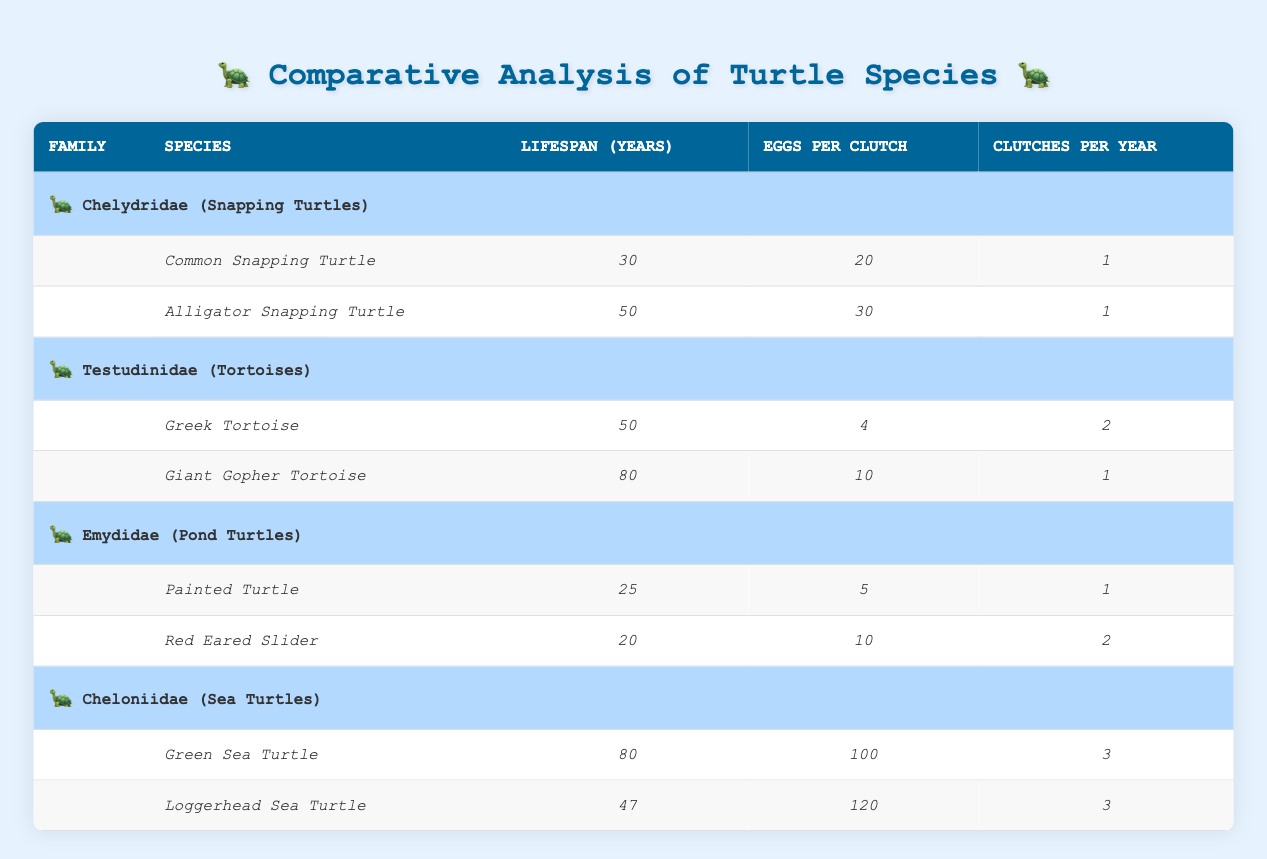What is the lifespan of the Common Snapping Turtle? The table lists the lifespan of the Common Snapping Turtle under the Chelydridae family, noting it is 30 years.
Answer: 30 years How many eggs does the Loggerhead Sea Turtle lay per clutch? The table specifies that the Loggerhead Sea Turtle lays 120 eggs per clutch, as shown in its reproductive rate under the Cheloniidae family.
Answer: 120 eggs Which family has the longest-lived species on average? The longest lifespan in the table is associated with the Giant Gopher Tortoise and the Green Sea Turtle, both having a lifespan of 80 years. Calculating the average of the longest lifespans from families: (80 + 80 + 50 + 50 + 47 + 30 + 25 + 20) / 8 = 50.625, showing that both families have species that significantly contribute to this average.
Answer: Testudinidae and Cheloniidae Is the Reproductive Rate of the Giant Gopher Tortoise higher than that of the Greek Tortoise? The Giant Gopher Tortoise has a reproductive rate of 10 eggs per clutch with 1 clutch per year, leading to a total of 10 eggs per year. In comparison, the Greek Tortoise has 4 eggs per clutch and 2 clutches per year, resulting in a total of 8 eggs per year. Therefore, the Giant Gopher Tortoise has a higher reproductive rate.
Answer: Yes What is the combined total of clutches per year for both species in the Emydidae family? The Emydidae family consists of the Painted Turtle and the Red Eared Slider. The Painted Turtle lays 1 clutch per year, while the Red Eared Slider lays 2 clutches per year. By adding these together, 1 + 2 = 3, we find the combined total of clutches is 3 per year.
Answer: 3 clutches per year Which species in the Cheloniidae family has a longer lifespan, and by how many years does it exceed the other? The Green Sea Turtle has a lifespan of 80 years, while the Loggerhead Sea Turtle has a lifespan of 47 years. The difference is 80 - 47 = 33 years, showing that the Green Sea Turtle exceeds Loggerhead Sea Turtle's lifespan by 33 years.
Answer: Green Sea Turtle; 33 years How many species within the Testudinidae family have a lifespan exceeding 60 years? Within the Testudinidae family, the Giant Gopher Tortoise (80 years) exceeds 60 years. The Greek Tortoise (50 years) does not exceed 60 years. Thus, the count of species exceeding 60 years in the Testudinidae family is 1.
Answer: 1 species Do all species in the Emydidae family have a reproductive rate greater than 5 eggs per clutch? The Painted Turtle lays 5 eggs per clutch, while the Red Eared Slider lays 10 eggs per clutch. Since both species either meet or exceed this rate, the answer is affirmative.
Answer: Yes 